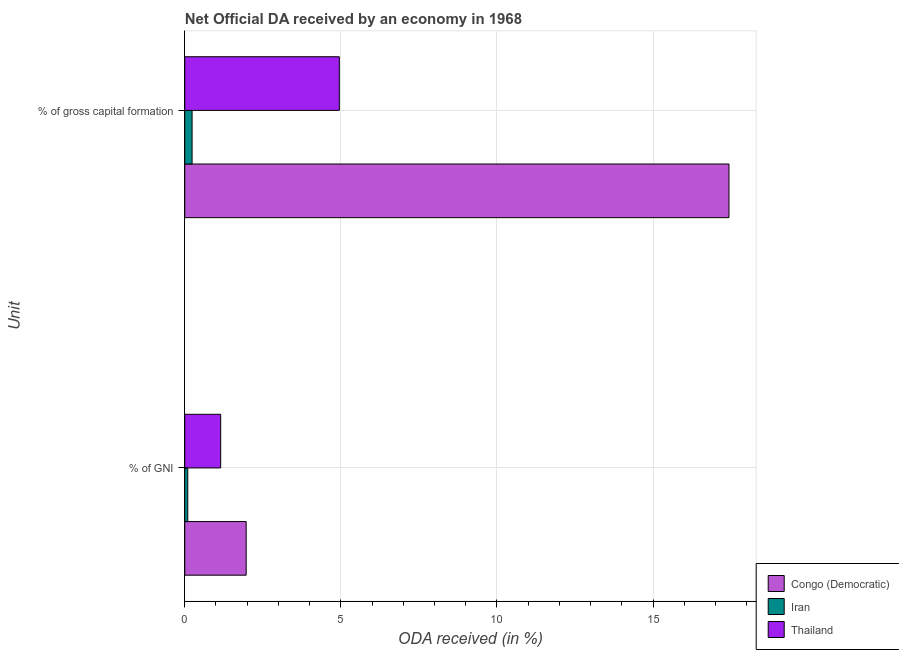How many groups of bars are there?
Your answer should be compact. 2. How many bars are there on the 1st tick from the top?
Provide a short and direct response. 3. What is the label of the 2nd group of bars from the top?
Give a very brief answer. % of GNI. What is the oda received as percentage of gross capital formation in Iran?
Ensure brevity in your answer.  0.23. Across all countries, what is the maximum oda received as percentage of gni?
Offer a very short reply. 1.97. Across all countries, what is the minimum oda received as percentage of gni?
Your response must be concise. 0.1. In which country was the oda received as percentage of gross capital formation maximum?
Provide a short and direct response. Congo (Democratic). In which country was the oda received as percentage of gross capital formation minimum?
Keep it short and to the point. Iran. What is the total oda received as percentage of gross capital formation in the graph?
Give a very brief answer. 22.62. What is the difference between the oda received as percentage of gni in Iran and that in Congo (Democratic)?
Provide a short and direct response. -1.87. What is the difference between the oda received as percentage of gni in Congo (Democratic) and the oda received as percentage of gross capital formation in Iran?
Give a very brief answer. 1.73. What is the average oda received as percentage of gross capital formation per country?
Ensure brevity in your answer.  7.54. What is the difference between the oda received as percentage of gni and oda received as percentage of gross capital formation in Congo (Democratic)?
Provide a short and direct response. -15.47. What is the ratio of the oda received as percentage of gni in Iran to that in Congo (Democratic)?
Offer a very short reply. 0.05. Is the oda received as percentage of gross capital formation in Congo (Democratic) less than that in Thailand?
Offer a terse response. No. In how many countries, is the oda received as percentage of gni greater than the average oda received as percentage of gni taken over all countries?
Give a very brief answer. 2. What does the 3rd bar from the top in % of gross capital formation represents?
Keep it short and to the point. Congo (Democratic). What does the 1st bar from the bottom in % of GNI represents?
Provide a short and direct response. Congo (Democratic). How many bars are there?
Provide a short and direct response. 6. Are all the bars in the graph horizontal?
Offer a terse response. Yes. How many countries are there in the graph?
Ensure brevity in your answer.  3. What is the difference between two consecutive major ticks on the X-axis?
Provide a short and direct response. 5. Are the values on the major ticks of X-axis written in scientific E-notation?
Ensure brevity in your answer.  No. Does the graph contain any zero values?
Your answer should be compact. No. Where does the legend appear in the graph?
Offer a very short reply. Bottom right. What is the title of the graph?
Ensure brevity in your answer.  Net Official DA received by an economy in 1968. Does "Curacao" appear as one of the legend labels in the graph?
Your answer should be compact. No. What is the label or title of the X-axis?
Offer a very short reply. ODA received (in %). What is the label or title of the Y-axis?
Your response must be concise. Unit. What is the ODA received (in %) in Congo (Democratic) in % of GNI?
Make the answer very short. 1.97. What is the ODA received (in %) in Iran in % of GNI?
Give a very brief answer. 0.1. What is the ODA received (in %) of Thailand in % of GNI?
Your response must be concise. 1.15. What is the ODA received (in %) of Congo (Democratic) in % of gross capital formation?
Give a very brief answer. 17.43. What is the ODA received (in %) of Iran in % of gross capital formation?
Provide a short and direct response. 0.23. What is the ODA received (in %) in Thailand in % of gross capital formation?
Your answer should be compact. 4.95. Across all Unit, what is the maximum ODA received (in %) in Congo (Democratic)?
Offer a terse response. 17.43. Across all Unit, what is the maximum ODA received (in %) in Iran?
Keep it short and to the point. 0.23. Across all Unit, what is the maximum ODA received (in %) in Thailand?
Your response must be concise. 4.95. Across all Unit, what is the minimum ODA received (in %) of Congo (Democratic)?
Provide a short and direct response. 1.97. Across all Unit, what is the minimum ODA received (in %) in Iran?
Ensure brevity in your answer.  0.1. Across all Unit, what is the minimum ODA received (in %) of Thailand?
Offer a terse response. 1.15. What is the total ODA received (in %) in Congo (Democratic) in the graph?
Your answer should be compact. 19.4. What is the total ODA received (in %) of Iran in the graph?
Your response must be concise. 0.33. What is the total ODA received (in %) of Thailand in the graph?
Ensure brevity in your answer.  6.1. What is the difference between the ODA received (in %) of Congo (Democratic) in % of GNI and that in % of gross capital formation?
Make the answer very short. -15.47. What is the difference between the ODA received (in %) in Iran in % of GNI and that in % of gross capital formation?
Your answer should be compact. -0.14. What is the difference between the ODA received (in %) of Thailand in % of GNI and that in % of gross capital formation?
Your answer should be compact. -3.8. What is the difference between the ODA received (in %) in Congo (Democratic) in % of GNI and the ODA received (in %) in Iran in % of gross capital formation?
Your answer should be very brief. 1.73. What is the difference between the ODA received (in %) in Congo (Democratic) in % of GNI and the ODA received (in %) in Thailand in % of gross capital formation?
Give a very brief answer. -2.98. What is the difference between the ODA received (in %) in Iran in % of GNI and the ODA received (in %) in Thailand in % of gross capital formation?
Provide a succinct answer. -4.86. What is the average ODA received (in %) in Congo (Democratic) per Unit?
Make the answer very short. 9.7. What is the average ODA received (in %) of Iran per Unit?
Ensure brevity in your answer.  0.17. What is the average ODA received (in %) in Thailand per Unit?
Your response must be concise. 3.05. What is the difference between the ODA received (in %) in Congo (Democratic) and ODA received (in %) in Iran in % of GNI?
Make the answer very short. 1.87. What is the difference between the ODA received (in %) in Congo (Democratic) and ODA received (in %) in Thailand in % of GNI?
Your answer should be very brief. 0.82. What is the difference between the ODA received (in %) of Iran and ODA received (in %) of Thailand in % of GNI?
Make the answer very short. -1.05. What is the difference between the ODA received (in %) in Congo (Democratic) and ODA received (in %) in Iran in % of gross capital formation?
Keep it short and to the point. 17.2. What is the difference between the ODA received (in %) of Congo (Democratic) and ODA received (in %) of Thailand in % of gross capital formation?
Offer a very short reply. 12.48. What is the difference between the ODA received (in %) of Iran and ODA received (in %) of Thailand in % of gross capital formation?
Provide a short and direct response. -4.72. What is the ratio of the ODA received (in %) in Congo (Democratic) in % of GNI to that in % of gross capital formation?
Make the answer very short. 0.11. What is the ratio of the ODA received (in %) in Iran in % of GNI to that in % of gross capital formation?
Your answer should be compact. 0.41. What is the ratio of the ODA received (in %) of Thailand in % of GNI to that in % of gross capital formation?
Provide a short and direct response. 0.23. What is the difference between the highest and the second highest ODA received (in %) in Congo (Democratic)?
Make the answer very short. 15.47. What is the difference between the highest and the second highest ODA received (in %) in Iran?
Provide a short and direct response. 0.14. What is the difference between the highest and the second highest ODA received (in %) of Thailand?
Offer a very short reply. 3.8. What is the difference between the highest and the lowest ODA received (in %) in Congo (Democratic)?
Ensure brevity in your answer.  15.47. What is the difference between the highest and the lowest ODA received (in %) of Iran?
Your answer should be compact. 0.14. What is the difference between the highest and the lowest ODA received (in %) of Thailand?
Provide a succinct answer. 3.8. 